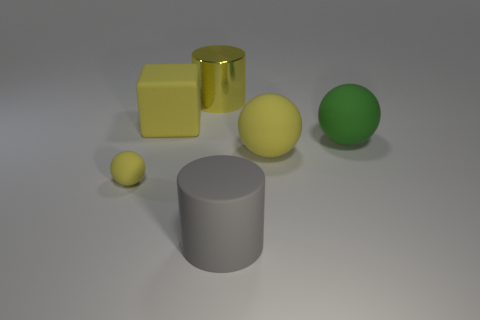Do the large yellow matte thing behind the green matte object and the yellow thing on the right side of the large gray rubber thing have the same shape?
Your response must be concise. No. There is a block that is the same size as the green sphere; what is its material?
Make the answer very short. Rubber. What number of other objects are there of the same material as the big yellow sphere?
Keep it short and to the point. 4. The large yellow rubber thing on the left side of the yellow sphere right of the tiny sphere is what shape?
Ensure brevity in your answer.  Cube. What number of objects are small cyan blocks or rubber balls on the left side of the metallic thing?
Ensure brevity in your answer.  1. How many other objects are the same color as the small rubber ball?
Keep it short and to the point. 3. What number of brown objects are matte cylinders or cubes?
Ensure brevity in your answer.  0. There is a yellow rubber ball to the left of the big cylinder that is behind the gray matte cylinder; are there any gray rubber cylinders that are in front of it?
Offer a terse response. Yes. Are there any other things that are the same size as the yellow cube?
Offer a very short reply. Yes. Does the tiny rubber object have the same color as the rubber block?
Your answer should be very brief. Yes. 